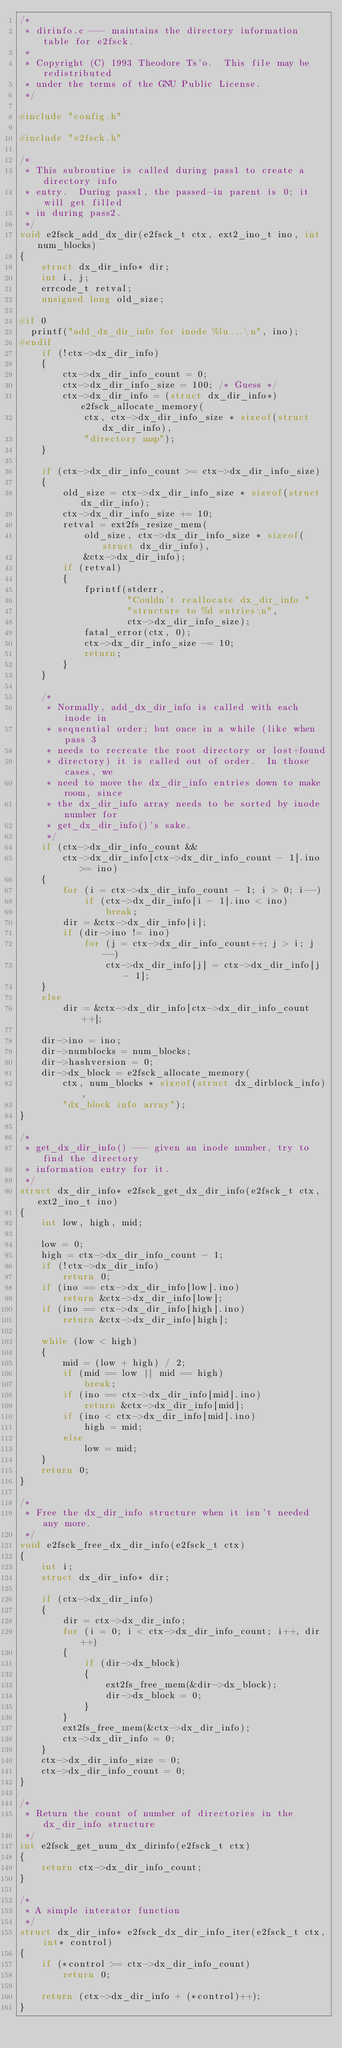<code> <loc_0><loc_0><loc_500><loc_500><_C_>/*
 * dirinfo.c --- maintains the directory information table for e2fsck.
 *
 * Copyright (C) 1993 Theodore Ts'o.  This file may be redistributed
 * under the terms of the GNU Public License.
 */

#include "config.h"

#include "e2fsck.h"

/*
 * This subroutine is called during pass1 to create a directory info
 * entry.  During pass1, the passed-in parent is 0; it will get filled
 * in during pass2.
 */
void e2fsck_add_dx_dir(e2fsck_t ctx, ext2_ino_t ino, int num_blocks)
{
    struct dx_dir_info* dir;
    int i, j;
    errcode_t retval;
    unsigned long old_size;

#if 0
	printf("add_dx_dir_info for inode %lu...\n", ino);
#endif
    if (!ctx->dx_dir_info)
    {
        ctx->dx_dir_info_count = 0;
        ctx->dx_dir_info_size = 100; /* Guess */
        ctx->dx_dir_info = (struct dx_dir_info*)e2fsck_allocate_memory(
            ctx, ctx->dx_dir_info_size * sizeof(struct dx_dir_info),
            "directory map");
    }

    if (ctx->dx_dir_info_count >= ctx->dx_dir_info_size)
    {
        old_size = ctx->dx_dir_info_size * sizeof(struct dx_dir_info);
        ctx->dx_dir_info_size += 10;
        retval = ext2fs_resize_mem(
            old_size, ctx->dx_dir_info_size * sizeof(struct dx_dir_info),
            &ctx->dx_dir_info);
        if (retval)
        {
            fprintf(stderr,
                    "Couldn't reallocate dx_dir_info "
                    "structure to %d entries\n",
                    ctx->dx_dir_info_size);
            fatal_error(ctx, 0);
            ctx->dx_dir_info_size -= 10;
            return;
        }
    }

    /*
     * Normally, add_dx_dir_info is called with each inode in
     * sequential order; but once in a while (like when pass 3
     * needs to recreate the root directory or lost+found
     * directory) it is called out of order.  In those cases, we
     * need to move the dx_dir_info entries down to make room, since
     * the dx_dir_info array needs to be sorted by inode number for
     * get_dx_dir_info()'s sake.
     */
    if (ctx->dx_dir_info_count &&
        ctx->dx_dir_info[ctx->dx_dir_info_count - 1].ino >= ino)
    {
        for (i = ctx->dx_dir_info_count - 1; i > 0; i--)
            if (ctx->dx_dir_info[i - 1].ino < ino)
                break;
        dir = &ctx->dx_dir_info[i];
        if (dir->ino != ino)
            for (j = ctx->dx_dir_info_count++; j > i; j--)
                ctx->dx_dir_info[j] = ctx->dx_dir_info[j - 1];
    }
    else
        dir = &ctx->dx_dir_info[ctx->dx_dir_info_count++];

    dir->ino = ino;
    dir->numblocks = num_blocks;
    dir->hashversion = 0;
    dir->dx_block = e2fsck_allocate_memory(
        ctx, num_blocks * sizeof(struct dx_dirblock_info),
        "dx_block info array");
}

/*
 * get_dx_dir_info() --- given an inode number, try to find the directory
 * information entry for it.
 */
struct dx_dir_info* e2fsck_get_dx_dir_info(e2fsck_t ctx, ext2_ino_t ino)
{
    int low, high, mid;

    low = 0;
    high = ctx->dx_dir_info_count - 1;
    if (!ctx->dx_dir_info)
        return 0;
    if (ino == ctx->dx_dir_info[low].ino)
        return &ctx->dx_dir_info[low];
    if (ino == ctx->dx_dir_info[high].ino)
        return &ctx->dx_dir_info[high];

    while (low < high)
    {
        mid = (low + high) / 2;
        if (mid == low || mid == high)
            break;
        if (ino == ctx->dx_dir_info[mid].ino)
            return &ctx->dx_dir_info[mid];
        if (ino < ctx->dx_dir_info[mid].ino)
            high = mid;
        else
            low = mid;
    }
    return 0;
}

/*
 * Free the dx_dir_info structure when it isn't needed any more.
 */
void e2fsck_free_dx_dir_info(e2fsck_t ctx)
{
    int i;
    struct dx_dir_info* dir;

    if (ctx->dx_dir_info)
    {
        dir = ctx->dx_dir_info;
        for (i = 0; i < ctx->dx_dir_info_count; i++, dir++)
        {
            if (dir->dx_block)
            {
                ext2fs_free_mem(&dir->dx_block);
                dir->dx_block = 0;
            }
        }
        ext2fs_free_mem(&ctx->dx_dir_info);
        ctx->dx_dir_info = 0;
    }
    ctx->dx_dir_info_size = 0;
    ctx->dx_dir_info_count = 0;
}

/*
 * Return the count of number of directories in the dx_dir_info structure
 */
int e2fsck_get_num_dx_dirinfo(e2fsck_t ctx)
{
    return ctx->dx_dir_info_count;
}

/*
 * A simple interator function
 */
struct dx_dir_info* e2fsck_dx_dir_info_iter(e2fsck_t ctx, int* control)
{
    if (*control >= ctx->dx_dir_info_count)
        return 0;

    return (ctx->dx_dir_info + (*control)++);
}
</code> 